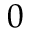<formula> <loc_0><loc_0><loc_500><loc_500>0</formula> 